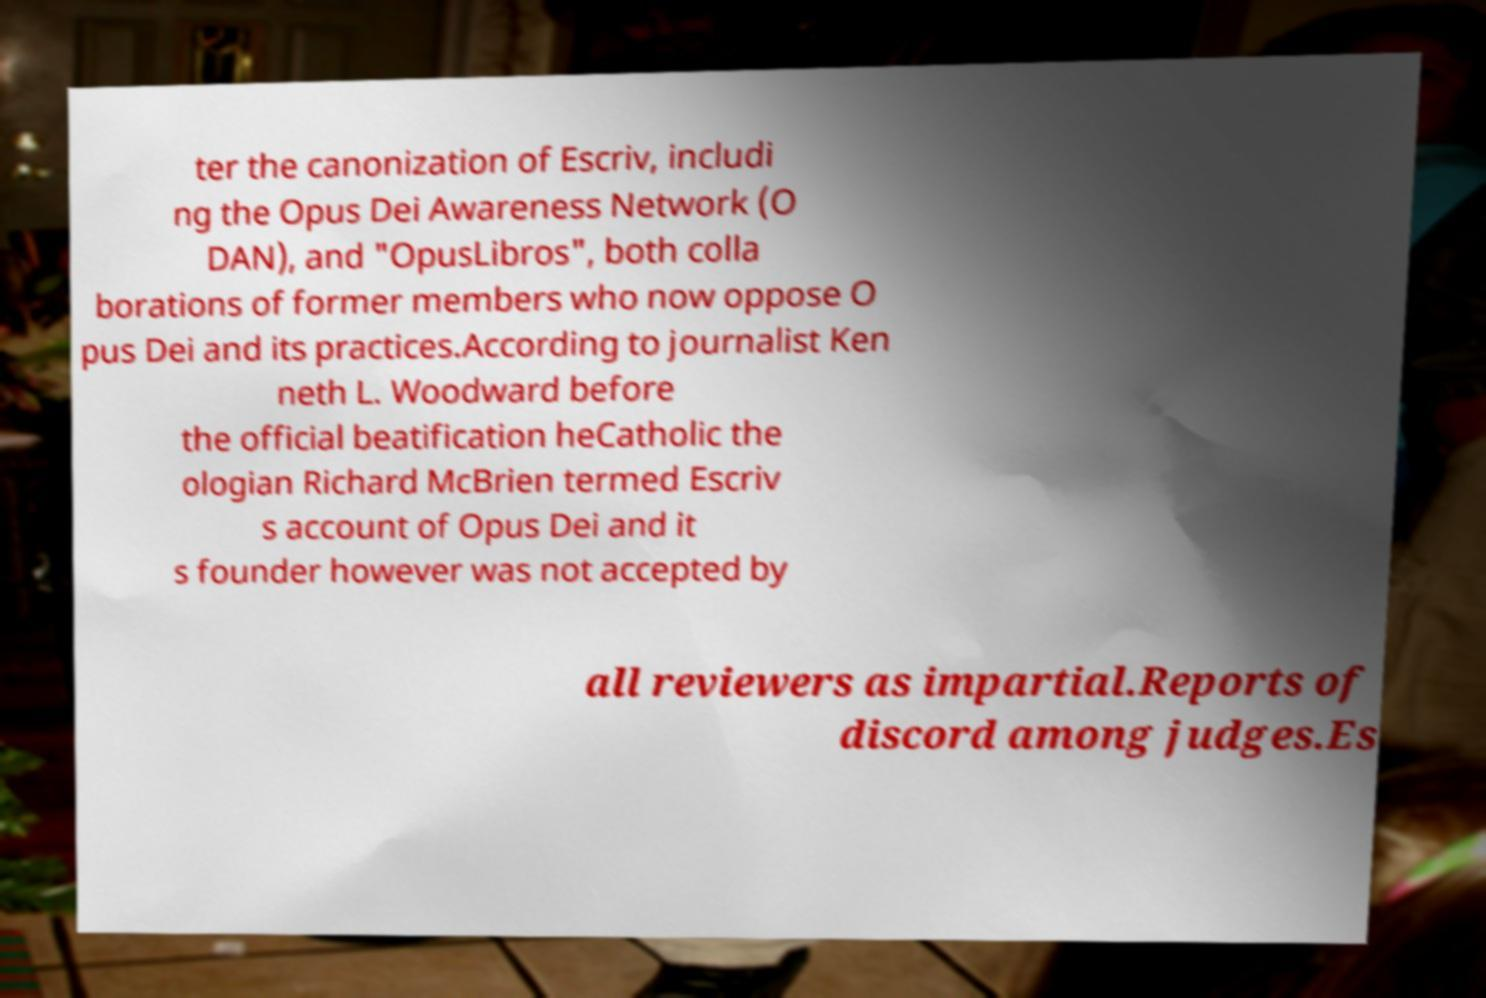Can you read and provide the text displayed in the image?This photo seems to have some interesting text. Can you extract and type it out for me? ter the canonization of Escriv, includi ng the Opus Dei Awareness Network (O DAN), and "OpusLibros", both colla borations of former members who now oppose O pus Dei and its practices.According to journalist Ken neth L. Woodward before the official beatification heCatholic the ologian Richard McBrien termed Escriv s account of Opus Dei and it s founder however was not accepted by all reviewers as impartial.Reports of discord among judges.Es 